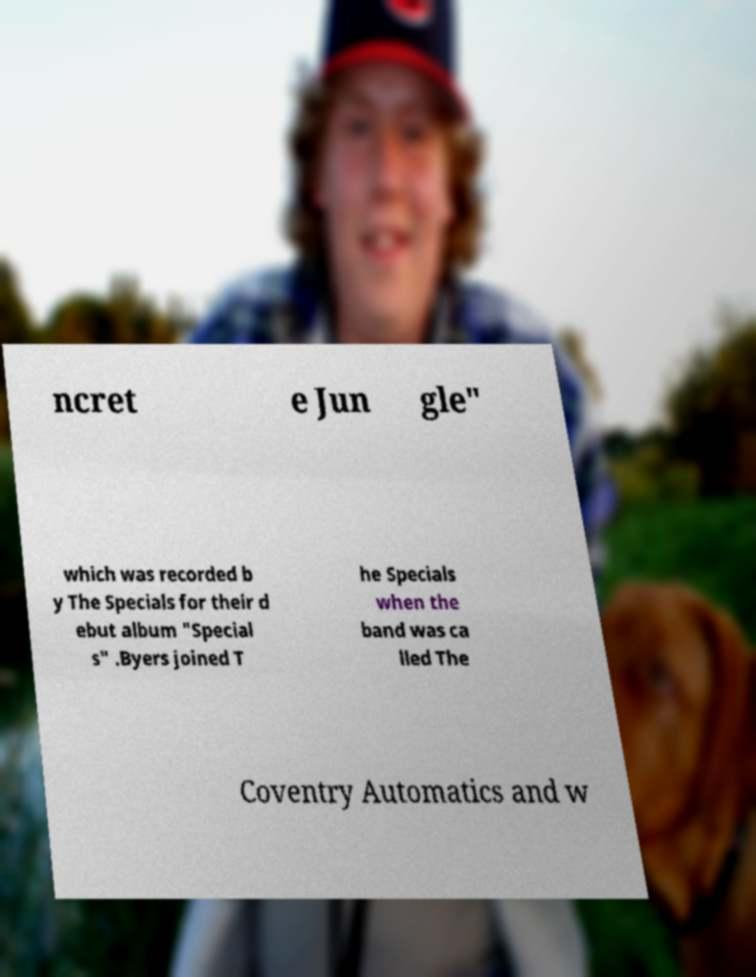Please identify and transcribe the text found in this image. ncret e Jun gle" which was recorded b y The Specials for their d ebut album "Special s" .Byers joined T he Specials when the band was ca lled The Coventry Automatics and w 